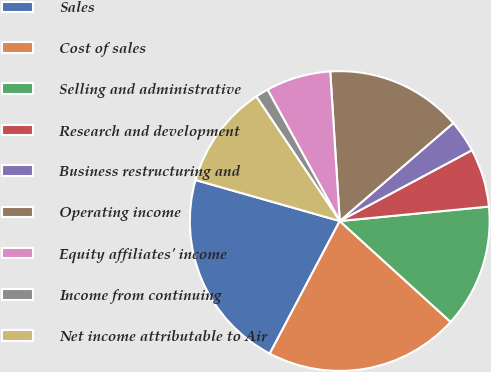Convert chart. <chart><loc_0><loc_0><loc_500><loc_500><pie_chart><fcel>Sales<fcel>Cost of sales<fcel>Selling and administrative<fcel>Research and development<fcel>Business restructuring and<fcel>Operating income<fcel>Equity affiliates' income<fcel>Income from continuing<fcel>Net income attributable to Air<nl><fcel>21.68%<fcel>20.98%<fcel>13.29%<fcel>6.29%<fcel>3.5%<fcel>14.68%<fcel>6.99%<fcel>1.4%<fcel>11.19%<nl></chart> 